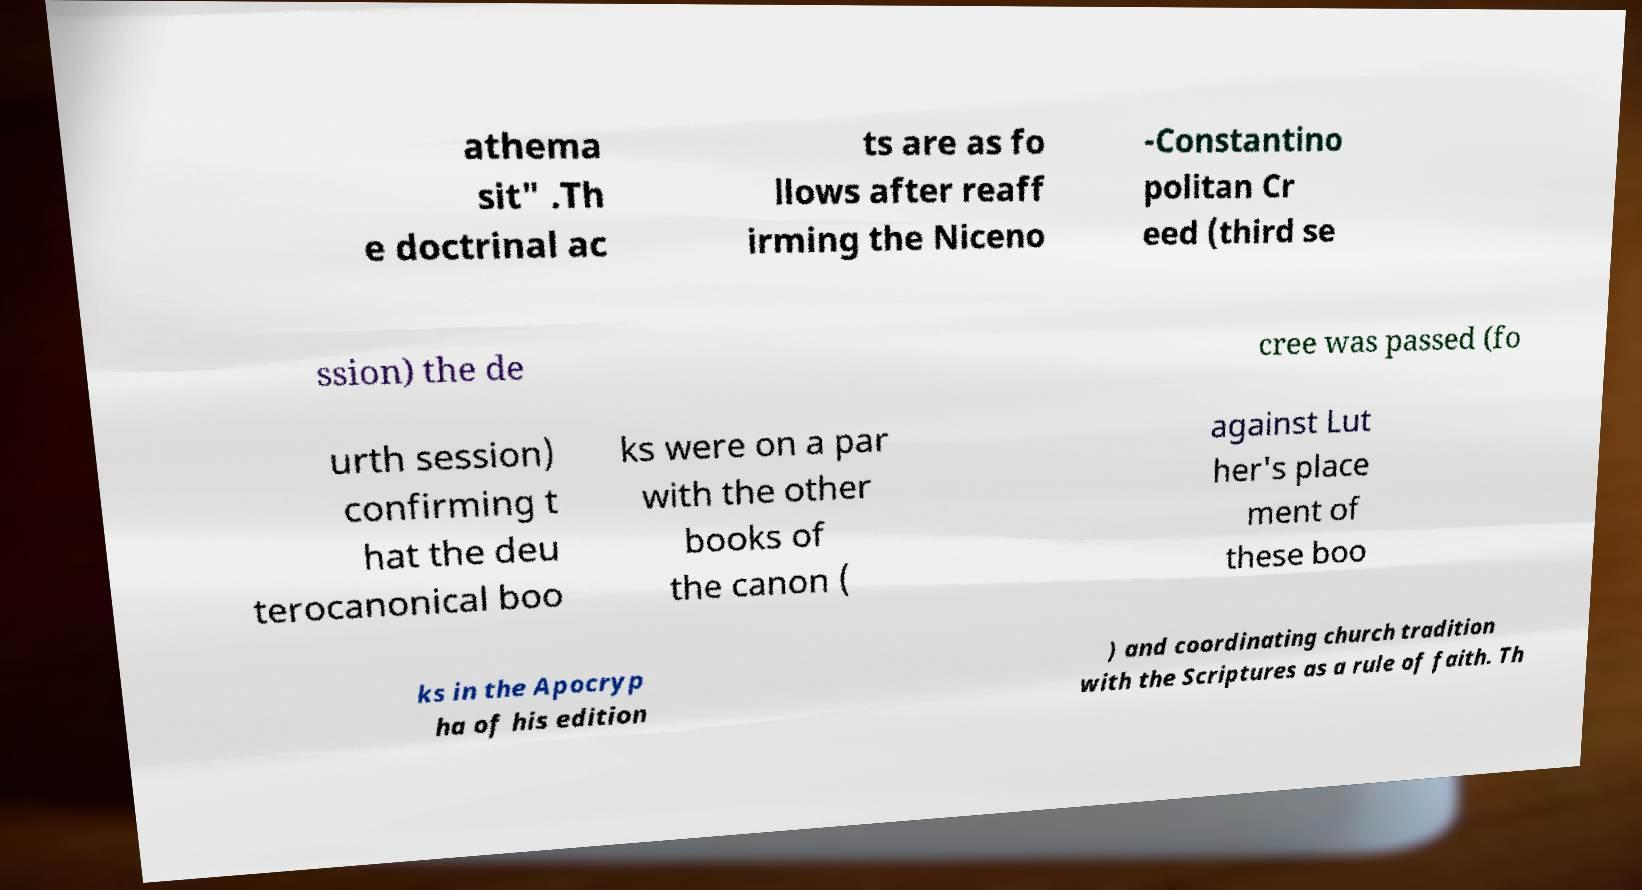Can you accurately transcribe the text from the provided image for me? athema sit" .Th e doctrinal ac ts are as fo llows after reaff irming the Niceno -Constantino politan Cr eed (third se ssion) the de cree was passed (fo urth session) confirming t hat the deu terocanonical boo ks were on a par with the other books of the canon ( against Lut her's place ment of these boo ks in the Apocryp ha of his edition ) and coordinating church tradition with the Scriptures as a rule of faith. Th 